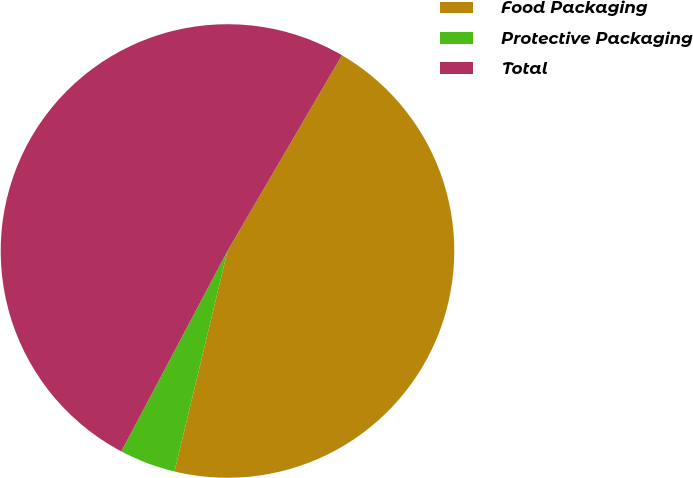Convert chart. <chart><loc_0><loc_0><loc_500><loc_500><pie_chart><fcel>Food Packaging<fcel>Protective Packaging<fcel>Total<nl><fcel>45.33%<fcel>4.0%<fcel>50.67%<nl></chart> 